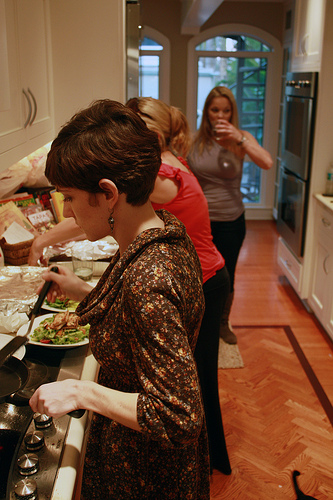What appliances can you see in the kitchen? Visible appliances include a stove with multiple burners and a double oven built into the wall. Describe the floor and its design. The floor has a beautiful wood finish with a classic herringbone pattern that adds an elegant and warm touch to the kitchen space. 